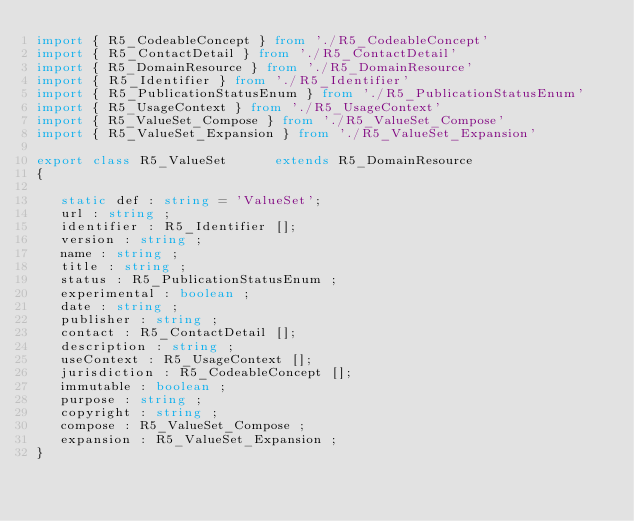Convert code to text. <code><loc_0><loc_0><loc_500><loc_500><_TypeScript_>import { R5_CodeableConcept } from './R5_CodeableConcept'
import { R5_ContactDetail } from './R5_ContactDetail'
import { R5_DomainResource } from './R5_DomainResource'
import { R5_Identifier } from './R5_Identifier'
import { R5_PublicationStatusEnum } from './R5_PublicationStatusEnum'
import { R5_UsageContext } from './R5_UsageContext'
import { R5_ValueSet_Compose } from './R5_ValueSet_Compose'
import { R5_ValueSet_Expansion } from './R5_ValueSet_Expansion'

export class R5_ValueSet      extends R5_DomainResource
{

   static def : string = 'ValueSet';
   url : string ;
   identifier : R5_Identifier [];
   version : string ;
   name : string ;
   title : string ;
   status : R5_PublicationStatusEnum ;
   experimental : boolean ;
   date : string ;
   publisher : string ;
   contact : R5_ContactDetail [];
   description : string ;
   useContext : R5_UsageContext [];
   jurisdiction : R5_CodeableConcept [];
   immutable : boolean ;
   purpose : string ;
   copyright : string ;
   compose : R5_ValueSet_Compose ;
   expansion : R5_ValueSet_Expansion ;
}
</code> 